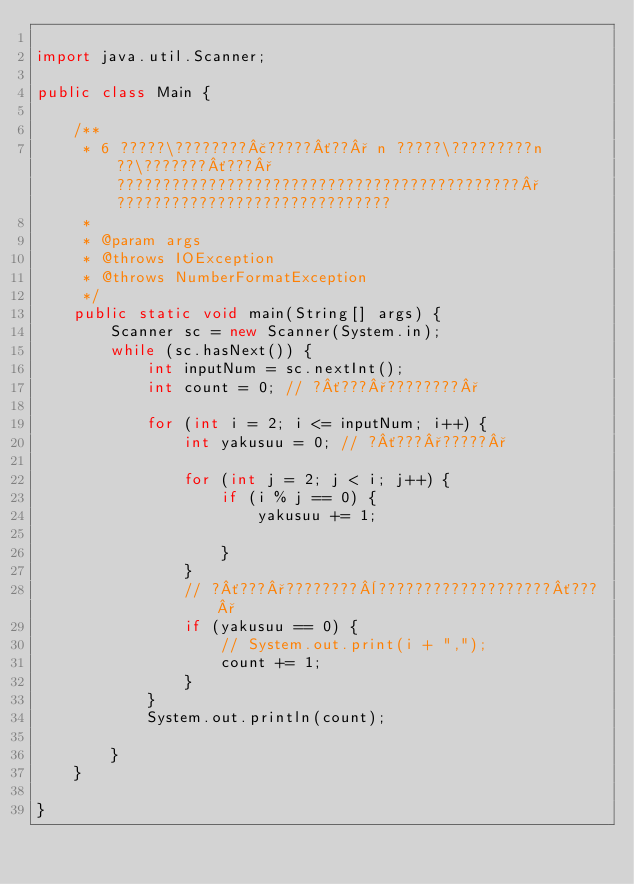Convert code to text. <code><loc_0><loc_0><loc_500><loc_500><_Java_>
import java.util.Scanner;

public class Main {

	/**
	 * 6 ?????\????????£?????´??° n ?????\?????????n ??\???????´???°????????????????????????????????????????????°??????????????????????????????
	 * 
	 * @param args
	 * @throws IOException
	 * @throws NumberFormatException
	 */
	public static void main(String[] args) {
		Scanner sc = new Scanner(System.in);
		while (sc.hasNext()) {
			int inputNum = sc.nextInt();
			int count = 0; // ?´???°????????°

			for (int i = 2; i <= inputNum; i++) {
				int yakusuu = 0; // ?´???°?????°

				for (int j = 2; j < i; j++) {
					if (i % j == 0) {
						yakusuu += 1;

					}
				}
				// ?´???°????????¨???????????????????´???°
				if (yakusuu == 0) {
					// System.out.print(i + ",");
					count += 1;
				}
			}
			System.out.println(count);

		}
	}

}</code> 